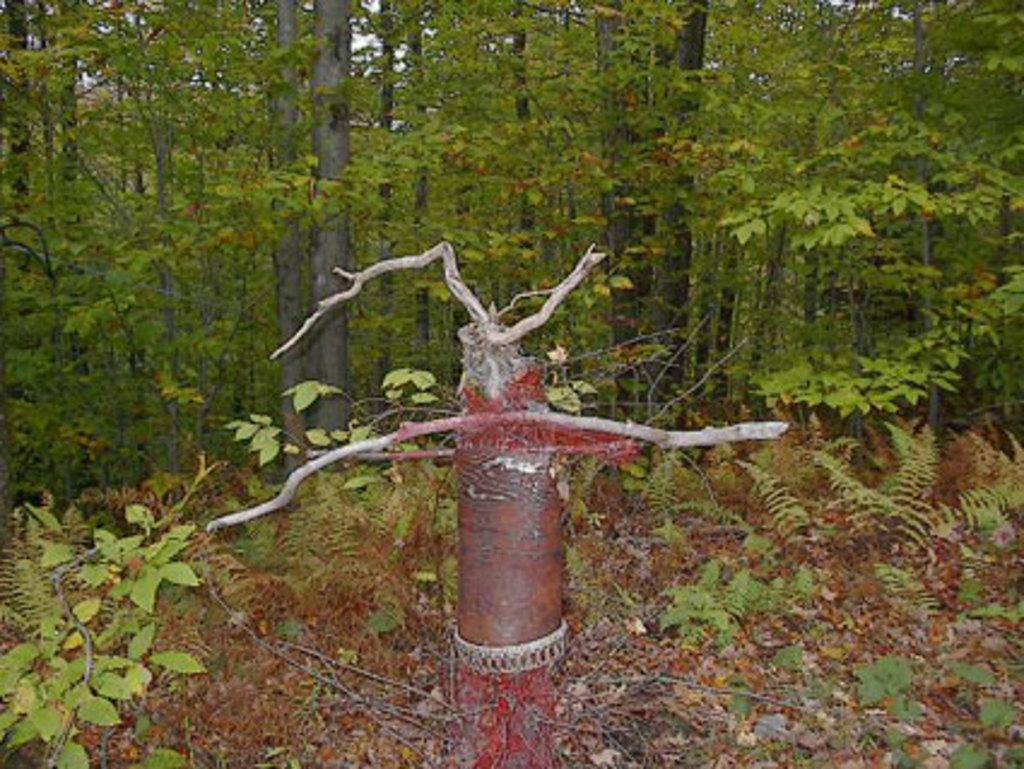What is located in the foreground of the image? There is a metal rod and plants in the foreground of the image. What type of vegetation is present in the foreground? There is grass in the foreground of the image. What can be seen in the background of the image? There are trees and the sky visible in the background of the image. What might be the location of the image based on the vegetation? The image may have been taken in a forest, given the presence of trees and grass. What type of dirt can be seen on the plant in the image? There is no dirt visible on the plants in the image; only the metal rod, plants, grass, trees, and sky are present. What hope does the plant in the image have for a better future? The image does not convey any information about the future or the plant's hopes, as it is a static representation of the scene. 